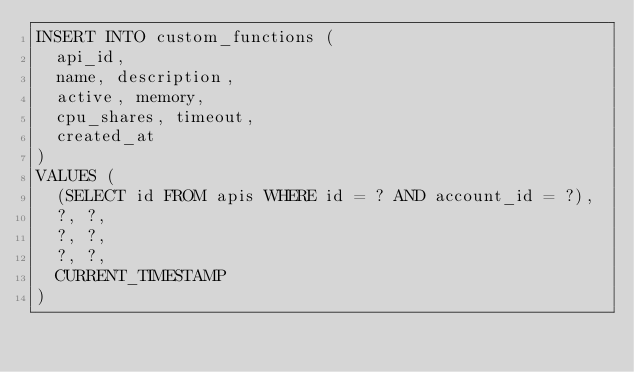Convert code to text. <code><loc_0><loc_0><loc_500><loc_500><_SQL_>INSERT INTO custom_functions (
  api_id,
  name, description,
  active, memory,
  cpu_shares, timeout,
  created_at
)
VALUES (
  (SELECT id FROM apis WHERE id = ? AND account_id = ?),
  ?, ?,
  ?, ?,
  ?, ?,
  CURRENT_TIMESTAMP
)
</code> 